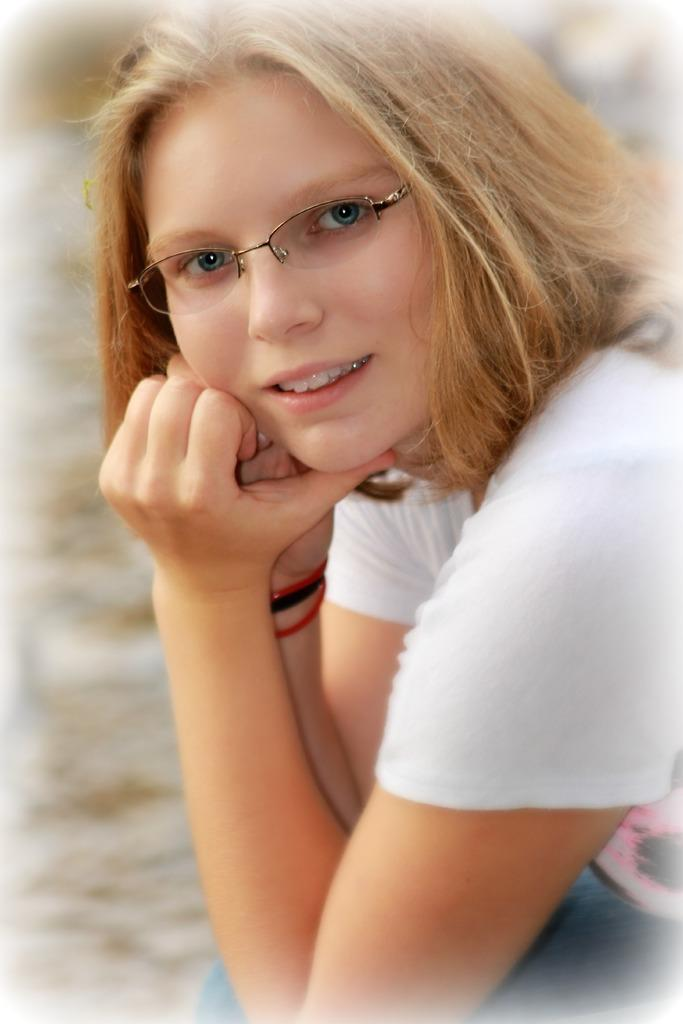Who is the main subject in the image? There is a lady in the center of the image. What is the lady doing in the image? The lady is sitting. What is the lady wearing on her upper body? The lady is wearing a white T-shirt. What is the lady wearing on her lower body? The lady is wearing jeans. What accessory is the lady wearing on her face? The lady is wearing spectacles. How would you describe the background of the image? The background of the image is blurred. What type of beast can be seen attacking the lady's elbow in the image? There is no beast present in the image, and the lady's elbow is not being attacked. 